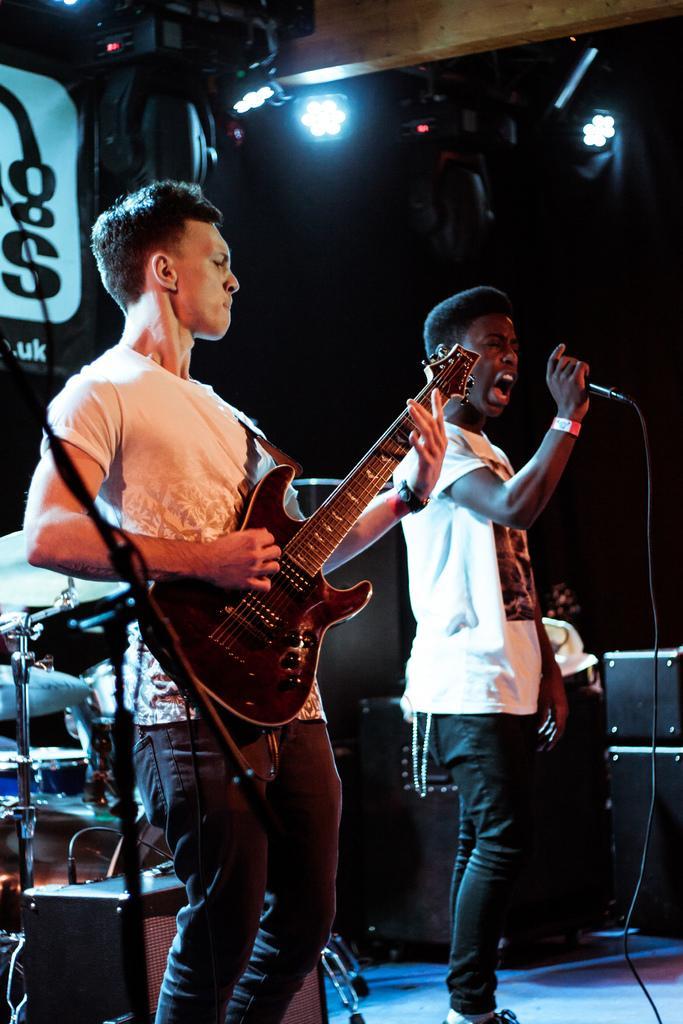Please provide a concise description of this image. In this image we can see this man is playing guitar and this man is singing through the mic in his hands. In the background we can see electronic drums, speakers and show lights. 